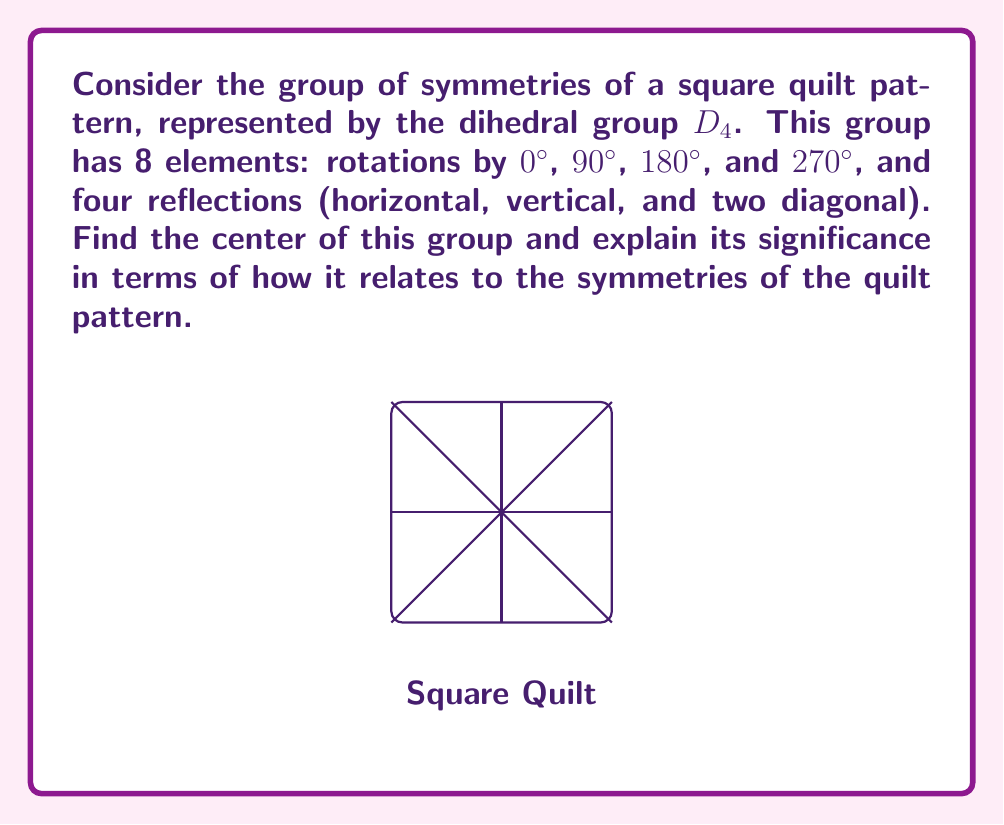Show me your answer to this math problem. To find the center of the group $D_4$, we need to identify the elements that commute with every other element in the group. Let's follow these steps:

1) Recall that the center of a group $G$ is defined as:
   $$Z(G) = \{z \in G : zg = gz \text{ for all } g \in G\}$$

2) In $D_4$, let's denote:
   - $r_0, r_1, r_2, r_3$ as rotations by 0°, 90°, 180°, 270° respectively
   - $f_h, f_v, f_d, f_d'$ as reflections (horizontal, vertical, diagonal, and other diagonal)

3) The identity element $r_0$ always commutes with every element, so it's always in the center.

4) Let's check the 180° rotation $r_2$:
   - It commutes with all rotations (obvious)
   - It also commutes with all reflections because $r_2f = fr_2$ for any reflection $f$
     (rotating 180° then reflecting is the same as reflecting then rotating 180°)

5) All other elements don't commute with at least one other element:
   - 90° and 270° rotations don't commute with reflections
   - Reflections don't commute with each other or with 90° and 270° rotations

6) Therefore, the center of $D_4$ is $\{r_0, r_2\}$, or in other words, the identity and the 180° rotation.

The significance of this result in terms of the quilt pattern is that the 180° rotation and the identity are the only symmetries that "play well" with all other symmetries. They can be applied before or after any other symmetry operation without changing the result. This means that these two operations are particularly special in preserving the overall symmetry of the quilt pattern, regardless of what other symmetry operations are applied.
Answer: $Z(D_4) = \{e, r_{180°}\}$ 